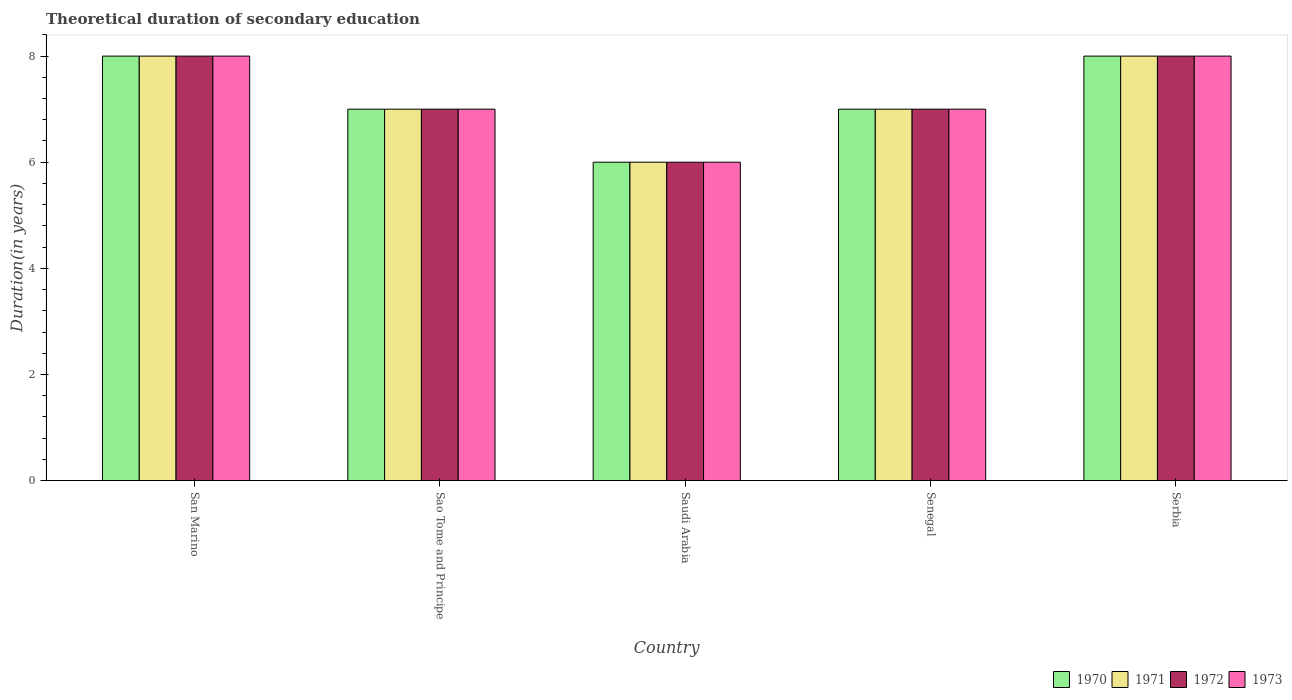How many groups of bars are there?
Make the answer very short. 5. Are the number of bars on each tick of the X-axis equal?
Ensure brevity in your answer.  Yes. How many bars are there on the 5th tick from the left?
Your answer should be very brief. 4. What is the label of the 1st group of bars from the left?
Your answer should be compact. San Marino. In how many cases, is the number of bars for a given country not equal to the number of legend labels?
Your answer should be very brief. 0. What is the total theoretical duration of secondary education in 1971 in Senegal?
Your response must be concise. 7. Across all countries, what is the maximum total theoretical duration of secondary education in 1971?
Keep it short and to the point. 8. Across all countries, what is the minimum total theoretical duration of secondary education in 1973?
Provide a succinct answer. 6. In which country was the total theoretical duration of secondary education in 1972 maximum?
Ensure brevity in your answer.  San Marino. In which country was the total theoretical duration of secondary education in 1971 minimum?
Give a very brief answer. Saudi Arabia. What is the total total theoretical duration of secondary education in 1972 in the graph?
Make the answer very short. 36. What is the ratio of the total theoretical duration of secondary education in 1971 in Sao Tome and Principe to that in Serbia?
Your answer should be compact. 0.88. Is the total theoretical duration of secondary education in 1972 in Sao Tome and Principe less than that in Senegal?
Ensure brevity in your answer.  No. Is it the case that in every country, the sum of the total theoretical duration of secondary education in 1972 and total theoretical duration of secondary education in 1971 is greater than the sum of total theoretical duration of secondary education in 1970 and total theoretical duration of secondary education in 1973?
Your response must be concise. No. Are all the bars in the graph horizontal?
Provide a succinct answer. No. Are the values on the major ticks of Y-axis written in scientific E-notation?
Provide a succinct answer. No. Where does the legend appear in the graph?
Offer a terse response. Bottom right. How many legend labels are there?
Your answer should be very brief. 4. What is the title of the graph?
Your answer should be very brief. Theoretical duration of secondary education. Does "2000" appear as one of the legend labels in the graph?
Keep it short and to the point. No. What is the label or title of the Y-axis?
Provide a succinct answer. Duration(in years). What is the Duration(in years) in 1970 in San Marino?
Make the answer very short. 8. What is the Duration(in years) in 1972 in San Marino?
Provide a succinct answer. 8. What is the Duration(in years) of 1970 in Sao Tome and Principe?
Ensure brevity in your answer.  7. What is the Duration(in years) of 1972 in Sao Tome and Principe?
Your answer should be very brief. 7. What is the Duration(in years) in 1970 in Saudi Arabia?
Your answer should be very brief. 6. What is the Duration(in years) of 1971 in Saudi Arabia?
Keep it short and to the point. 6. What is the Duration(in years) of 1972 in Saudi Arabia?
Offer a terse response. 6. What is the Duration(in years) of 1970 in Senegal?
Provide a short and direct response. 7. What is the Duration(in years) in 1971 in Senegal?
Keep it short and to the point. 7. What is the Duration(in years) of 1970 in Serbia?
Provide a short and direct response. 8. Across all countries, what is the maximum Duration(in years) of 1971?
Offer a terse response. 8. Across all countries, what is the maximum Duration(in years) in 1972?
Keep it short and to the point. 8. Across all countries, what is the maximum Duration(in years) of 1973?
Your answer should be very brief. 8. Across all countries, what is the minimum Duration(in years) in 1970?
Keep it short and to the point. 6. Across all countries, what is the minimum Duration(in years) of 1971?
Offer a very short reply. 6. What is the total Duration(in years) of 1972 in the graph?
Your response must be concise. 36. What is the difference between the Duration(in years) of 1972 in San Marino and that in Sao Tome and Principe?
Keep it short and to the point. 1. What is the difference between the Duration(in years) of 1970 in San Marino and that in Saudi Arabia?
Your answer should be compact. 2. What is the difference between the Duration(in years) in 1971 in San Marino and that in Saudi Arabia?
Your answer should be compact. 2. What is the difference between the Duration(in years) of 1972 in San Marino and that in Saudi Arabia?
Provide a short and direct response. 2. What is the difference between the Duration(in years) in 1970 in San Marino and that in Senegal?
Make the answer very short. 1. What is the difference between the Duration(in years) in 1973 in San Marino and that in Serbia?
Your answer should be compact. 0. What is the difference between the Duration(in years) in 1970 in Sao Tome and Principe and that in Saudi Arabia?
Give a very brief answer. 1. What is the difference between the Duration(in years) in 1971 in Sao Tome and Principe and that in Saudi Arabia?
Offer a terse response. 1. What is the difference between the Duration(in years) in 1972 in Sao Tome and Principe and that in Saudi Arabia?
Keep it short and to the point. 1. What is the difference between the Duration(in years) of 1973 in Sao Tome and Principe and that in Saudi Arabia?
Ensure brevity in your answer.  1. What is the difference between the Duration(in years) of 1972 in Sao Tome and Principe and that in Senegal?
Give a very brief answer. 0. What is the difference between the Duration(in years) in 1973 in Sao Tome and Principe and that in Serbia?
Offer a terse response. -1. What is the difference between the Duration(in years) in 1973 in Saudi Arabia and that in Senegal?
Your answer should be very brief. -1. What is the difference between the Duration(in years) of 1970 in Saudi Arabia and that in Serbia?
Offer a terse response. -2. What is the difference between the Duration(in years) in 1973 in Saudi Arabia and that in Serbia?
Offer a very short reply. -2. What is the difference between the Duration(in years) of 1970 in Senegal and that in Serbia?
Keep it short and to the point. -1. What is the difference between the Duration(in years) in 1973 in Senegal and that in Serbia?
Offer a very short reply. -1. What is the difference between the Duration(in years) in 1970 in San Marino and the Duration(in years) in 1972 in Sao Tome and Principe?
Keep it short and to the point. 1. What is the difference between the Duration(in years) of 1970 in San Marino and the Duration(in years) of 1973 in Sao Tome and Principe?
Make the answer very short. 1. What is the difference between the Duration(in years) in 1971 in San Marino and the Duration(in years) in 1972 in Sao Tome and Principe?
Ensure brevity in your answer.  1. What is the difference between the Duration(in years) in 1971 in San Marino and the Duration(in years) in 1973 in Sao Tome and Principe?
Your response must be concise. 1. What is the difference between the Duration(in years) of 1970 in San Marino and the Duration(in years) of 1972 in Saudi Arabia?
Keep it short and to the point. 2. What is the difference between the Duration(in years) in 1971 in San Marino and the Duration(in years) in 1972 in Saudi Arabia?
Provide a short and direct response. 2. What is the difference between the Duration(in years) in 1971 in San Marino and the Duration(in years) in 1973 in Saudi Arabia?
Ensure brevity in your answer.  2. What is the difference between the Duration(in years) of 1970 in San Marino and the Duration(in years) of 1971 in Senegal?
Offer a terse response. 1. What is the difference between the Duration(in years) in 1970 in San Marino and the Duration(in years) in 1973 in Senegal?
Your answer should be very brief. 1. What is the difference between the Duration(in years) of 1971 in San Marino and the Duration(in years) of 1973 in Senegal?
Your answer should be very brief. 1. What is the difference between the Duration(in years) in 1970 in San Marino and the Duration(in years) in 1971 in Serbia?
Provide a succinct answer. 0. What is the difference between the Duration(in years) of 1970 in San Marino and the Duration(in years) of 1972 in Serbia?
Your answer should be very brief. 0. What is the difference between the Duration(in years) in 1971 in San Marino and the Duration(in years) in 1972 in Serbia?
Your response must be concise. 0. What is the difference between the Duration(in years) in 1972 in San Marino and the Duration(in years) in 1973 in Serbia?
Offer a very short reply. 0. What is the difference between the Duration(in years) of 1970 in Sao Tome and Principe and the Duration(in years) of 1972 in Saudi Arabia?
Provide a succinct answer. 1. What is the difference between the Duration(in years) of 1970 in Sao Tome and Principe and the Duration(in years) of 1973 in Saudi Arabia?
Your answer should be very brief. 1. What is the difference between the Duration(in years) in 1971 in Sao Tome and Principe and the Duration(in years) in 1972 in Saudi Arabia?
Provide a short and direct response. 1. What is the difference between the Duration(in years) in 1971 in Sao Tome and Principe and the Duration(in years) in 1973 in Saudi Arabia?
Ensure brevity in your answer.  1. What is the difference between the Duration(in years) in 1972 in Sao Tome and Principe and the Duration(in years) in 1973 in Saudi Arabia?
Provide a short and direct response. 1. What is the difference between the Duration(in years) in 1970 in Sao Tome and Principe and the Duration(in years) in 1973 in Senegal?
Your answer should be compact. 0. What is the difference between the Duration(in years) in 1970 in Sao Tome and Principe and the Duration(in years) in 1972 in Serbia?
Provide a succinct answer. -1. What is the difference between the Duration(in years) of 1970 in Sao Tome and Principe and the Duration(in years) of 1973 in Serbia?
Provide a succinct answer. -1. What is the difference between the Duration(in years) in 1971 in Sao Tome and Principe and the Duration(in years) in 1973 in Serbia?
Your answer should be very brief. -1. What is the difference between the Duration(in years) of 1972 in Sao Tome and Principe and the Duration(in years) of 1973 in Serbia?
Your answer should be very brief. -1. What is the difference between the Duration(in years) of 1970 in Saudi Arabia and the Duration(in years) of 1971 in Senegal?
Ensure brevity in your answer.  -1. What is the difference between the Duration(in years) in 1970 in Saudi Arabia and the Duration(in years) in 1972 in Senegal?
Make the answer very short. -1. What is the difference between the Duration(in years) in 1971 in Saudi Arabia and the Duration(in years) in 1972 in Senegal?
Offer a very short reply. -1. What is the difference between the Duration(in years) in 1971 in Saudi Arabia and the Duration(in years) in 1973 in Senegal?
Your answer should be very brief. -1. What is the difference between the Duration(in years) in 1971 in Saudi Arabia and the Duration(in years) in 1973 in Serbia?
Offer a very short reply. -2. What is the difference between the Duration(in years) in 1970 in Senegal and the Duration(in years) in 1973 in Serbia?
Provide a succinct answer. -1. What is the average Duration(in years) of 1970 per country?
Offer a terse response. 7.2. What is the average Duration(in years) of 1973 per country?
Keep it short and to the point. 7.2. What is the difference between the Duration(in years) of 1970 and Duration(in years) of 1972 in San Marino?
Your answer should be very brief. 0. What is the difference between the Duration(in years) in 1971 and Duration(in years) in 1973 in San Marino?
Your response must be concise. 0. What is the difference between the Duration(in years) of 1970 and Duration(in years) of 1971 in Sao Tome and Principe?
Provide a short and direct response. 0. What is the difference between the Duration(in years) of 1971 and Duration(in years) of 1973 in Sao Tome and Principe?
Provide a short and direct response. 0. What is the difference between the Duration(in years) of 1972 and Duration(in years) of 1973 in Sao Tome and Principe?
Provide a short and direct response. 0. What is the difference between the Duration(in years) of 1970 and Duration(in years) of 1972 in Saudi Arabia?
Your answer should be compact. 0. What is the difference between the Duration(in years) of 1972 and Duration(in years) of 1973 in Saudi Arabia?
Ensure brevity in your answer.  0. What is the difference between the Duration(in years) in 1970 and Duration(in years) in 1971 in Senegal?
Give a very brief answer. 0. What is the difference between the Duration(in years) of 1970 and Duration(in years) of 1973 in Senegal?
Your answer should be compact. 0. What is the difference between the Duration(in years) of 1971 and Duration(in years) of 1973 in Senegal?
Make the answer very short. 0. What is the difference between the Duration(in years) in 1970 and Duration(in years) in 1971 in Serbia?
Offer a terse response. 0. What is the difference between the Duration(in years) in 1970 and Duration(in years) in 1973 in Serbia?
Keep it short and to the point. 0. What is the difference between the Duration(in years) in 1972 and Duration(in years) in 1973 in Serbia?
Your answer should be very brief. 0. What is the ratio of the Duration(in years) in 1973 in San Marino to that in Sao Tome and Principe?
Ensure brevity in your answer.  1.14. What is the ratio of the Duration(in years) in 1971 in San Marino to that in Saudi Arabia?
Your answer should be compact. 1.33. What is the ratio of the Duration(in years) of 1972 in San Marino to that in Saudi Arabia?
Make the answer very short. 1.33. What is the ratio of the Duration(in years) of 1973 in San Marino to that in Senegal?
Provide a short and direct response. 1.14. What is the ratio of the Duration(in years) of 1970 in San Marino to that in Serbia?
Provide a short and direct response. 1. What is the ratio of the Duration(in years) in 1970 in Sao Tome and Principe to that in Saudi Arabia?
Keep it short and to the point. 1.17. What is the ratio of the Duration(in years) of 1972 in Sao Tome and Principe to that in Saudi Arabia?
Your answer should be very brief. 1.17. What is the ratio of the Duration(in years) of 1973 in Sao Tome and Principe to that in Saudi Arabia?
Offer a terse response. 1.17. What is the ratio of the Duration(in years) of 1970 in Sao Tome and Principe to that in Senegal?
Give a very brief answer. 1. What is the ratio of the Duration(in years) in 1971 in Sao Tome and Principe to that in Senegal?
Make the answer very short. 1. What is the ratio of the Duration(in years) in 1972 in Sao Tome and Principe to that in Senegal?
Make the answer very short. 1. What is the ratio of the Duration(in years) in 1970 in Sao Tome and Principe to that in Serbia?
Your answer should be compact. 0.88. What is the ratio of the Duration(in years) of 1971 in Sao Tome and Principe to that in Serbia?
Ensure brevity in your answer.  0.88. What is the ratio of the Duration(in years) in 1972 in Sao Tome and Principe to that in Serbia?
Ensure brevity in your answer.  0.88. What is the ratio of the Duration(in years) in 1973 in Sao Tome and Principe to that in Serbia?
Ensure brevity in your answer.  0.88. What is the ratio of the Duration(in years) in 1970 in Saudi Arabia to that in Senegal?
Your response must be concise. 0.86. What is the ratio of the Duration(in years) of 1972 in Saudi Arabia to that in Senegal?
Your answer should be very brief. 0.86. What is the ratio of the Duration(in years) in 1973 in Saudi Arabia to that in Senegal?
Your answer should be compact. 0.86. What is the ratio of the Duration(in years) of 1972 in Saudi Arabia to that in Serbia?
Your answer should be very brief. 0.75. What is the ratio of the Duration(in years) in 1971 in Senegal to that in Serbia?
Offer a terse response. 0.88. What is the difference between the highest and the second highest Duration(in years) of 1970?
Ensure brevity in your answer.  0. What is the difference between the highest and the second highest Duration(in years) of 1973?
Ensure brevity in your answer.  0. What is the difference between the highest and the lowest Duration(in years) of 1971?
Provide a short and direct response. 2. 